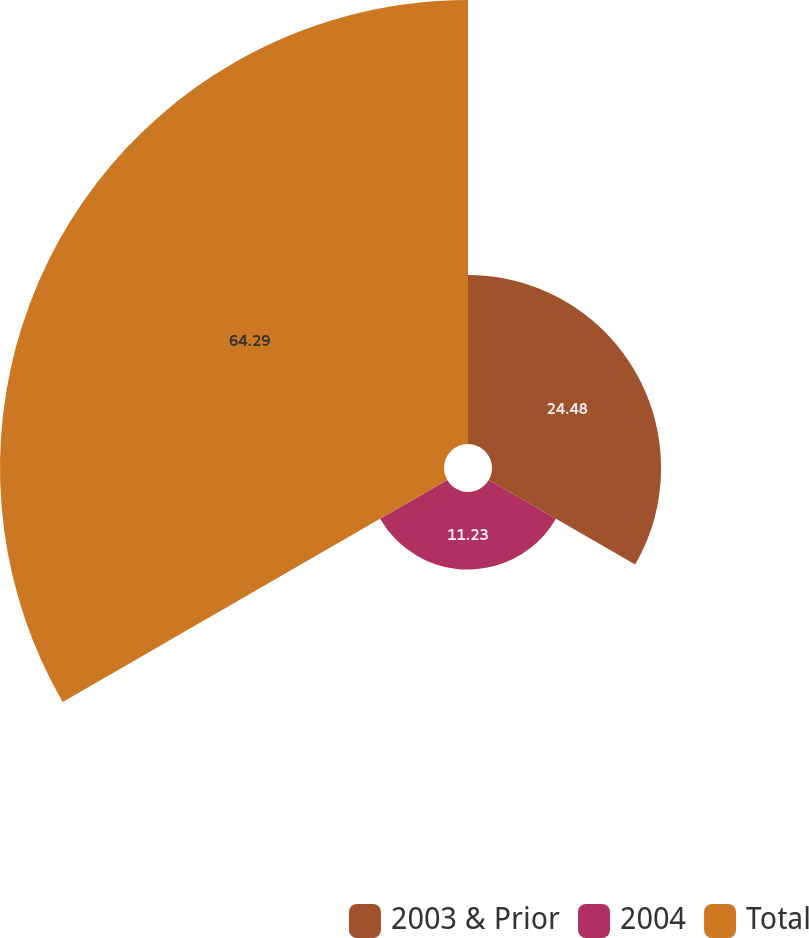Convert chart to OTSL. <chart><loc_0><loc_0><loc_500><loc_500><pie_chart><fcel>2003 & Prior<fcel>2004<fcel>Total<nl><fcel>24.48%<fcel>11.23%<fcel>64.29%<nl></chart> 